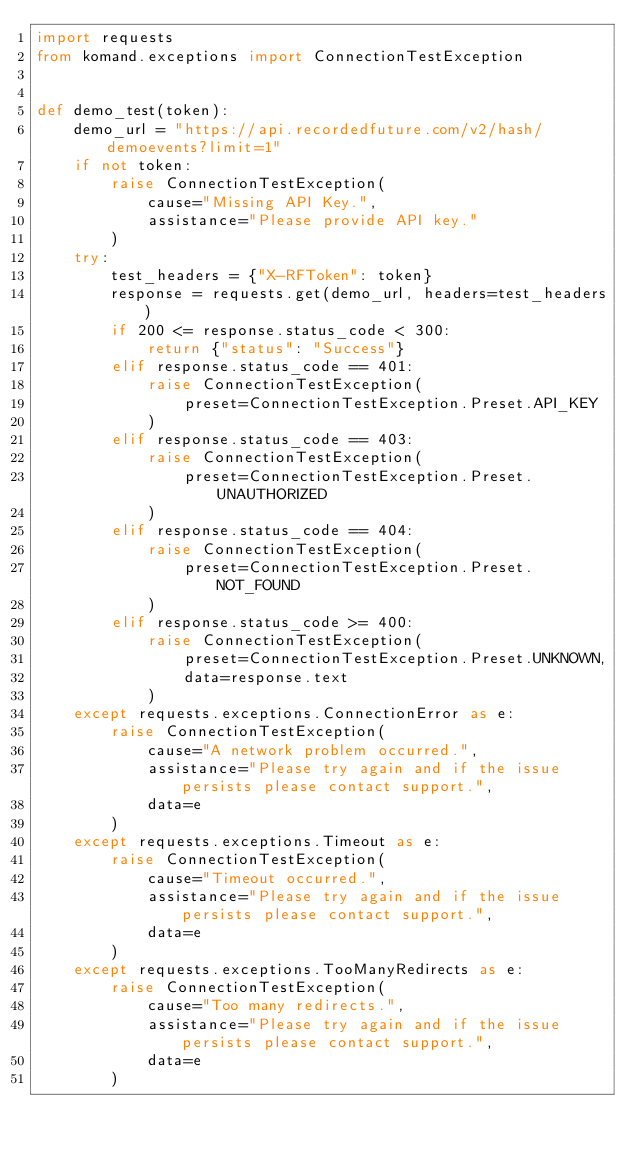Convert code to text. <code><loc_0><loc_0><loc_500><loc_500><_Python_>import requests
from komand.exceptions import ConnectionTestException


def demo_test(token):
    demo_url = "https://api.recordedfuture.com/v2/hash/demoevents?limit=1"
    if not token:
        raise ConnectionTestException(
            cause="Missing API Key.",
            assistance="Please provide API key."
        )
    try:
        test_headers = {"X-RFToken": token}
        response = requests.get(demo_url, headers=test_headers)
        if 200 <= response.status_code < 300:
            return {"status": "Success"}
        elif response.status_code == 401:
            raise ConnectionTestException(
                preset=ConnectionTestException.Preset.API_KEY
            )
        elif response.status_code == 403:
            raise ConnectionTestException(
                preset=ConnectionTestException.Preset.UNAUTHORIZED
            )
        elif response.status_code == 404:
            raise ConnectionTestException(
                preset=ConnectionTestException.Preset.NOT_FOUND
            )
        elif response.status_code >= 400:
            raise ConnectionTestException(
                preset=ConnectionTestException.Preset.UNKNOWN,
                data=response.text
            )
    except requests.exceptions.ConnectionError as e:
        raise ConnectionTestException(
            cause="A network problem occurred.",
            assistance="Please try again and if the issue persists please contact support.",
            data=e
        )
    except requests.exceptions.Timeout as e:
        raise ConnectionTestException(
            cause="Timeout occurred.",
            assistance="Please try again and if the issue persists please contact support.",
            data=e
        )
    except requests.exceptions.TooManyRedirects as e:
        raise ConnectionTestException(
            cause="Too many redirects.",
            assistance="Please try again and if the issue persists please contact support.",
            data=e
        )
</code> 